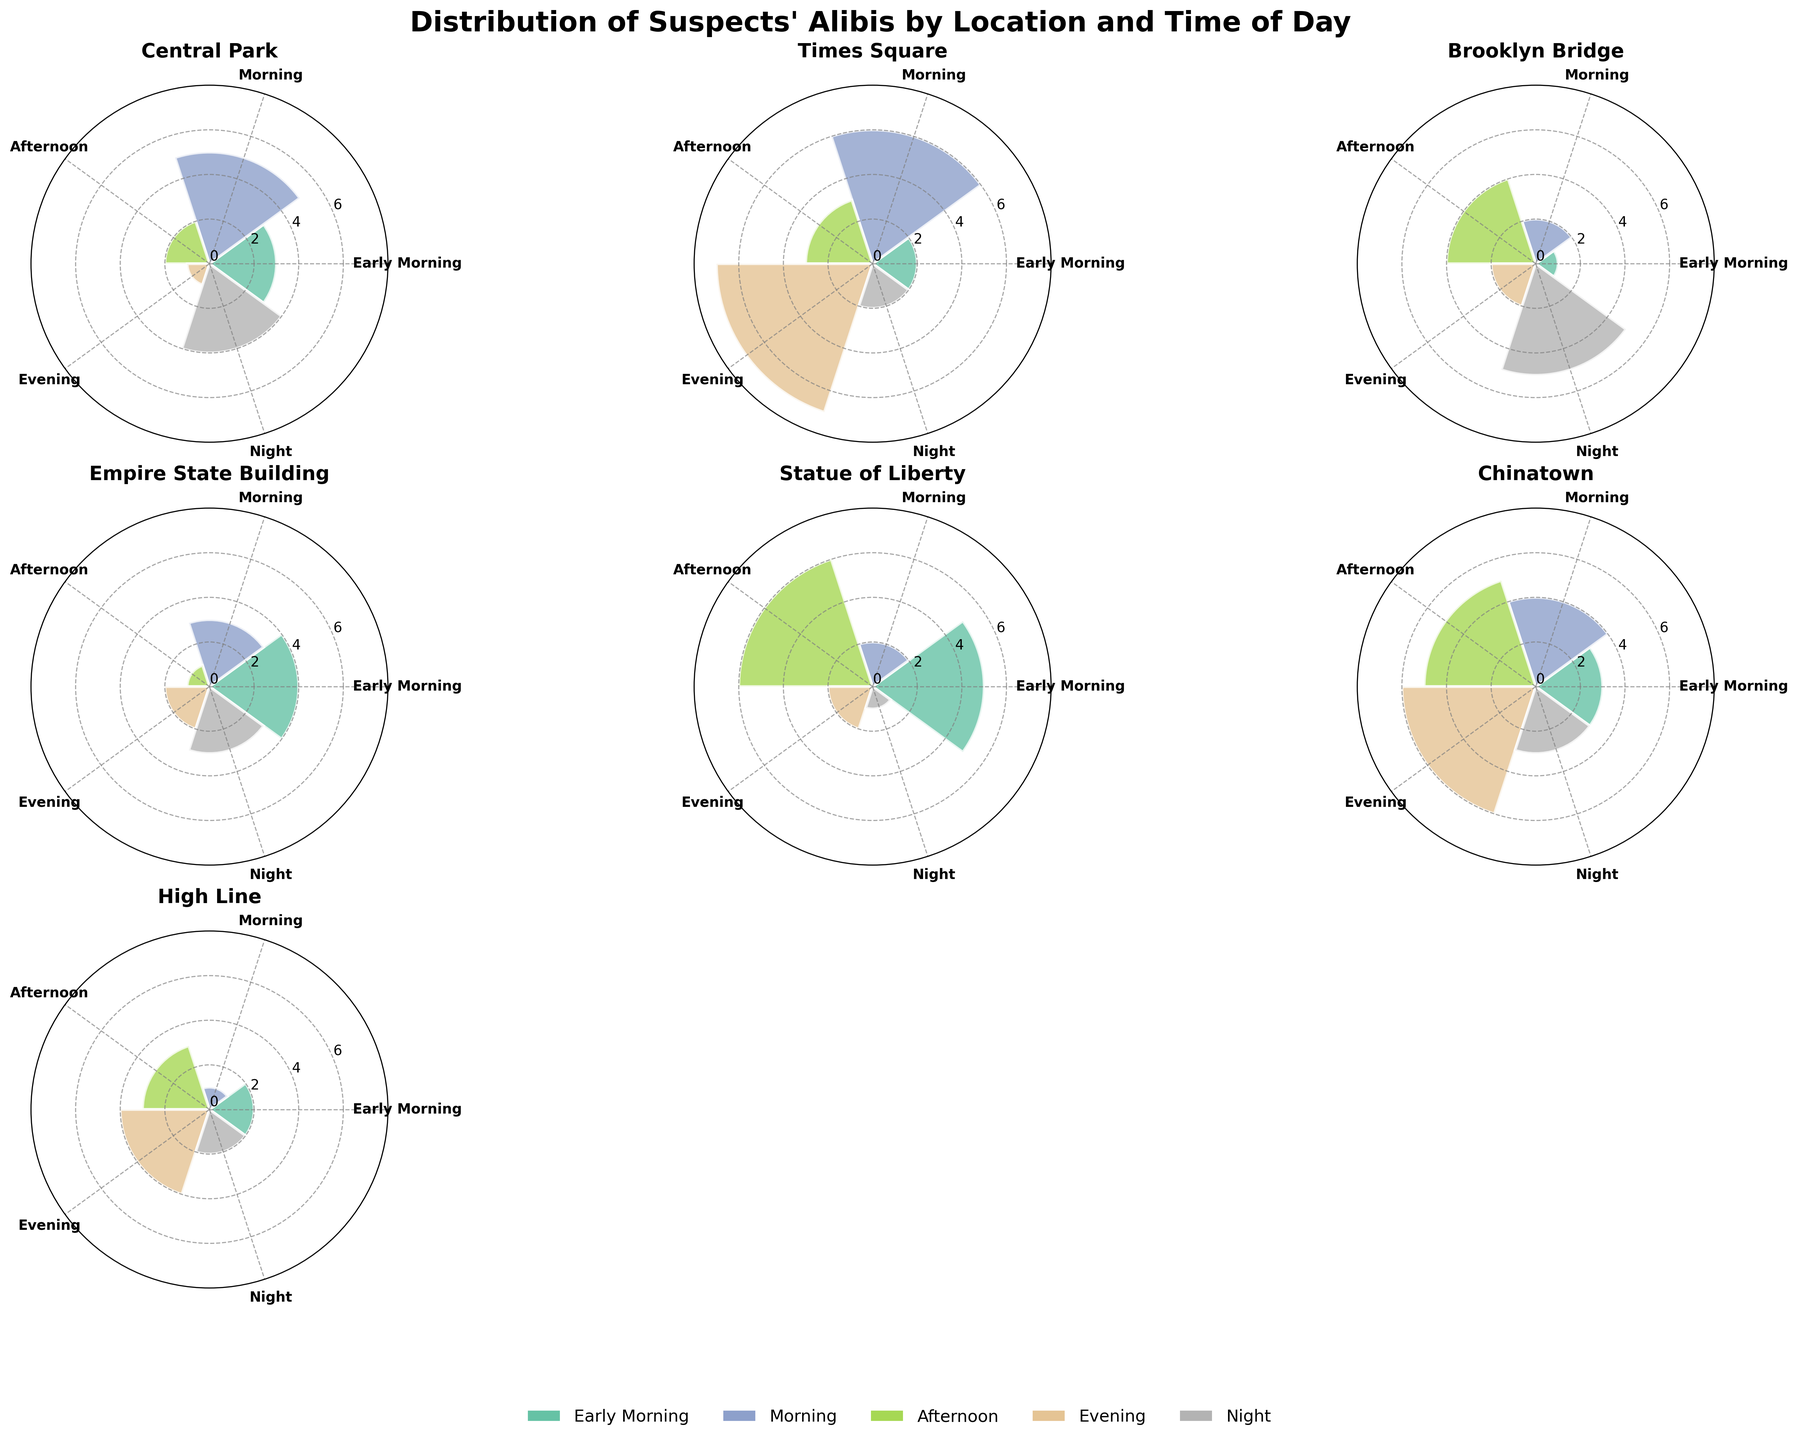Which location has the highest number of suspects in the Evening? To find the highest number of suspects in the Evening, look at the height of the bars corresponding to the 'Evening' category for each location. The location with the tallest bar in that category has the highest number.
Answer: Times Square How many suspects were accounted for at the Empire State Building only during the Early Morning and Morning combined? Sum the counts for the Early Morning and Morning categories at the Empire State Building. These counts are 4 and 3, respectively. Adding these gives 4+3.
Answer: 7 Which time of day has the least number of suspects at Central Park? Examine each bar for Central Park and find the shortest one. The shortest bar corresponds to the time with the least suspects.
Answer: Evening Is the count of suspects in Afternoon for Brooklyn Bridge greater than in Afternoon for High Line? Compare the bar heights of Brooklyn Bridge and High Line in the Afternoon category. Brooklyn Bridge has a count of 4, while High Line has a count of 3.
Answer: Yes How many total suspects were present at Times Square at Night and Chinatown at Night? Sum the counts for Times Square at Night and Chinatown at Night. These counts are 2 and 3, respectively. Adding these gives 2+3.
Answer: 5 Which location has the highest variation in suspects' counts across different times of day? Inspect the heights of the bars for each location and determine the one with the most varied (largest range between highest and lowest). For example, comparing the highest (7 for Evening) and lowest (2 for Early Morning and Night) counts in Times Square gives the largest difference.
Answer: Times Square Which location has the highest number of suspects in the Early Morning? Look at the bars for the Early Morning category and identify the tallest one across all locations.
Answer: Statue of Liberty What's the difference in the number of suspects in Morning between Central Park and Statue of Liberty? Compare the counts for the Morning time at Central Park and Statue of Liberty. Central Park has 5 and Statue of Liberty has 2. Calculate the difference, 5-2.
Answer: 3 During which time of day is the number of suspects the same across all locations? Identify if any time of day has the same bar height across all locations. Inspecting all times, there isn't a time where all locations have the same count.
Answer: None At which time of day do we see the highest peak across all locations? Evaluate all the bars and find the highest overall bar regardless of location. The tallest bar is the Evening category in Times Square with a count of 7.
Answer: Evening 